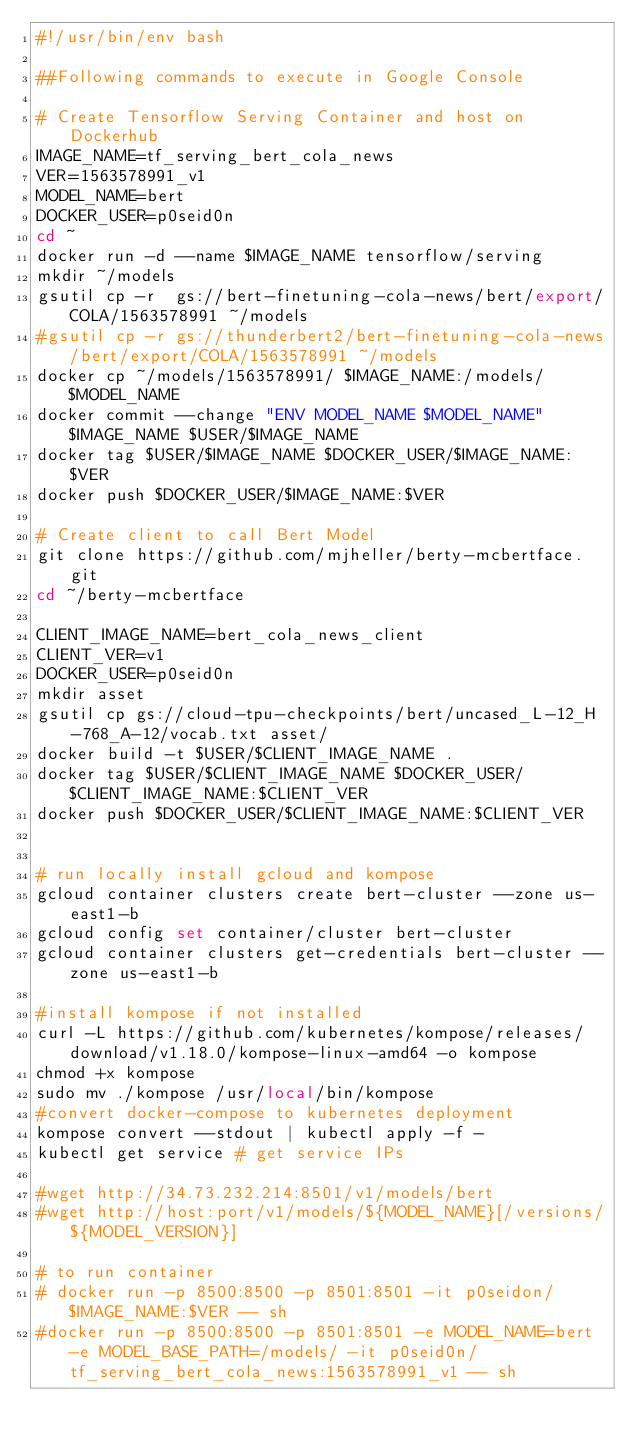Convert code to text. <code><loc_0><loc_0><loc_500><loc_500><_Bash_>#!/usr/bin/env bash

##Following commands to execute in Google Console

# Create Tensorflow Serving Container and host on Dockerhub
IMAGE_NAME=tf_serving_bert_cola_news
VER=1563578991_v1
MODEL_NAME=bert
DOCKER_USER=p0seid0n
cd ~
docker run -d --name $IMAGE_NAME tensorflow/serving
mkdir ~/models
gsutil cp -r  gs://bert-finetuning-cola-news/bert/export/COLA/1563578991 ~/models
#gsutil cp -r gs://thunderbert2/bert-finetuning-cola-news/bert/export/COLA/1563578991 ~/models
docker cp ~/models/1563578991/ $IMAGE_NAME:/models/$MODEL_NAME
docker commit --change "ENV MODEL_NAME $MODEL_NAME" $IMAGE_NAME $USER/$IMAGE_NAME
docker tag $USER/$IMAGE_NAME $DOCKER_USER/$IMAGE_NAME:$VER
docker push $DOCKER_USER/$IMAGE_NAME:$VER

# Create client to call Bert Model
git clone https://github.com/mjheller/berty-mcbertface.git
cd ~/berty-mcbertface

CLIENT_IMAGE_NAME=bert_cola_news_client
CLIENT_VER=v1
DOCKER_USER=p0seid0n
mkdir asset
gsutil cp gs://cloud-tpu-checkpoints/bert/uncased_L-12_H-768_A-12/vocab.txt asset/
docker build -t $USER/$CLIENT_IMAGE_NAME .
docker tag $USER/$CLIENT_IMAGE_NAME $DOCKER_USER/$CLIENT_IMAGE_NAME:$CLIENT_VER
docker push $DOCKER_USER/$CLIENT_IMAGE_NAME:$CLIENT_VER


# run locally install gcloud and kompose
gcloud container clusters create bert-cluster --zone us-east1-b
gcloud config set container/cluster bert-cluster
gcloud container clusters get-credentials bert-cluster --zone us-east1-b

#install kompose if not installed
curl -L https://github.com/kubernetes/kompose/releases/download/v1.18.0/kompose-linux-amd64 -o kompose
chmod +x kompose
sudo mv ./kompose /usr/local/bin/kompose
#convert docker-compose to kubernetes deployment
kompose convert --stdout | kubectl apply -f -
kubectl get service # get service IPs

#wget http://34.73.232.214:8501/v1/models/bert
#wget http://host:port/v1/models/${MODEL_NAME}[/versions/${MODEL_VERSION}]

# to run container
# docker run -p 8500:8500 -p 8501:8501 -it p0seidon/$IMAGE_NAME:$VER -- sh
#docker run -p 8500:8500 -p 8501:8501 -e MODEL_NAME=bert -e MODEL_BASE_PATH=/models/ -it p0seid0n/tf_serving_bert_cola_news:1563578991_v1 -- sh
</code> 